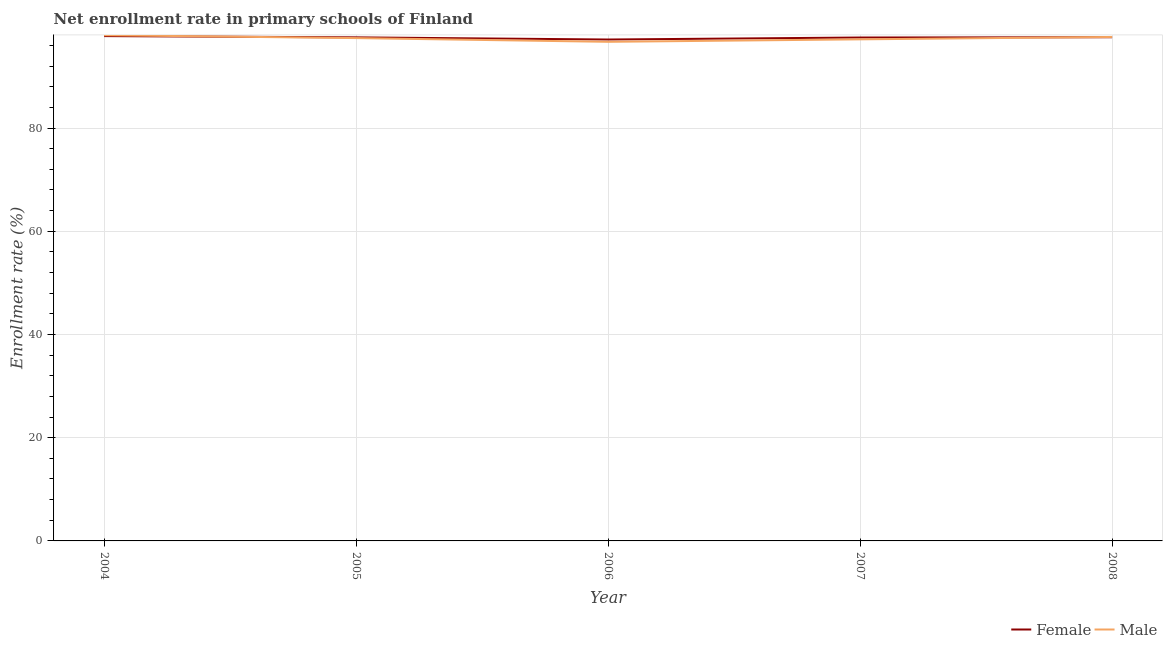Is the number of lines equal to the number of legend labels?
Make the answer very short. Yes. What is the enrollment rate of female students in 2007?
Your answer should be compact. 97.54. Across all years, what is the maximum enrollment rate of female students?
Provide a succinct answer. 97.82. Across all years, what is the minimum enrollment rate of male students?
Offer a terse response. 96.71. In which year was the enrollment rate of female students maximum?
Provide a short and direct response. 2004. What is the total enrollment rate of female students in the graph?
Provide a succinct answer. 487.68. What is the difference between the enrollment rate of male students in 2004 and that in 2005?
Offer a terse response. 0.56. What is the difference between the enrollment rate of male students in 2005 and the enrollment rate of female students in 2004?
Keep it short and to the point. -0.39. What is the average enrollment rate of female students per year?
Your answer should be very brief. 97.54. In the year 2008, what is the difference between the enrollment rate of male students and enrollment rate of female students?
Provide a short and direct response. 0.05. In how many years, is the enrollment rate of female students greater than 40 %?
Offer a very short reply. 5. What is the ratio of the enrollment rate of male students in 2006 to that in 2007?
Your answer should be compact. 1. Is the difference between the enrollment rate of female students in 2004 and 2005 greater than the difference between the enrollment rate of male students in 2004 and 2005?
Your answer should be very brief. No. What is the difference between the highest and the second highest enrollment rate of female students?
Your answer should be compact. 0.22. What is the difference between the highest and the lowest enrollment rate of female students?
Make the answer very short. 0.66. Does the enrollment rate of female students monotonically increase over the years?
Keep it short and to the point. No. Is the enrollment rate of male students strictly greater than the enrollment rate of female students over the years?
Offer a very short reply. No. Is the enrollment rate of male students strictly less than the enrollment rate of female students over the years?
Ensure brevity in your answer.  No. How many years are there in the graph?
Offer a terse response. 5. What is the difference between two consecutive major ticks on the Y-axis?
Offer a terse response. 20. Does the graph contain grids?
Ensure brevity in your answer.  Yes. What is the title of the graph?
Offer a terse response. Net enrollment rate in primary schools of Finland. What is the label or title of the X-axis?
Offer a very short reply. Year. What is the label or title of the Y-axis?
Make the answer very short. Enrollment rate (%). What is the Enrollment rate (%) of Female in 2004?
Keep it short and to the point. 97.82. What is the Enrollment rate (%) of Male in 2004?
Your answer should be compact. 97.99. What is the Enrollment rate (%) of Female in 2005?
Offer a very short reply. 97.57. What is the Enrollment rate (%) in Male in 2005?
Offer a terse response. 97.43. What is the Enrollment rate (%) of Female in 2006?
Provide a short and direct response. 97.15. What is the Enrollment rate (%) in Male in 2006?
Keep it short and to the point. 96.71. What is the Enrollment rate (%) of Female in 2007?
Provide a succinct answer. 97.54. What is the Enrollment rate (%) in Male in 2007?
Offer a terse response. 97.19. What is the Enrollment rate (%) of Female in 2008?
Provide a succinct answer. 97.6. What is the Enrollment rate (%) in Male in 2008?
Provide a short and direct response. 97.65. Across all years, what is the maximum Enrollment rate (%) of Female?
Ensure brevity in your answer.  97.82. Across all years, what is the maximum Enrollment rate (%) of Male?
Provide a succinct answer. 97.99. Across all years, what is the minimum Enrollment rate (%) in Female?
Offer a terse response. 97.15. Across all years, what is the minimum Enrollment rate (%) in Male?
Make the answer very short. 96.71. What is the total Enrollment rate (%) in Female in the graph?
Your answer should be very brief. 487.68. What is the total Enrollment rate (%) of Male in the graph?
Provide a short and direct response. 486.96. What is the difference between the Enrollment rate (%) of Female in 2004 and that in 2005?
Provide a succinct answer. 0.24. What is the difference between the Enrollment rate (%) in Male in 2004 and that in 2005?
Your answer should be very brief. 0.56. What is the difference between the Enrollment rate (%) in Female in 2004 and that in 2006?
Your answer should be very brief. 0.66. What is the difference between the Enrollment rate (%) in Male in 2004 and that in 2006?
Keep it short and to the point. 1.28. What is the difference between the Enrollment rate (%) in Female in 2004 and that in 2007?
Your response must be concise. 0.27. What is the difference between the Enrollment rate (%) in Male in 2004 and that in 2007?
Ensure brevity in your answer.  0.8. What is the difference between the Enrollment rate (%) in Female in 2004 and that in 2008?
Offer a terse response. 0.22. What is the difference between the Enrollment rate (%) in Male in 2004 and that in 2008?
Offer a terse response. 0.34. What is the difference between the Enrollment rate (%) in Female in 2005 and that in 2006?
Offer a very short reply. 0.42. What is the difference between the Enrollment rate (%) of Male in 2005 and that in 2006?
Keep it short and to the point. 0.72. What is the difference between the Enrollment rate (%) of Female in 2005 and that in 2007?
Provide a short and direct response. 0.03. What is the difference between the Enrollment rate (%) of Male in 2005 and that in 2007?
Offer a very short reply. 0.24. What is the difference between the Enrollment rate (%) in Female in 2005 and that in 2008?
Offer a very short reply. -0.03. What is the difference between the Enrollment rate (%) of Male in 2005 and that in 2008?
Give a very brief answer. -0.22. What is the difference between the Enrollment rate (%) of Female in 2006 and that in 2007?
Your response must be concise. -0.39. What is the difference between the Enrollment rate (%) of Male in 2006 and that in 2007?
Offer a terse response. -0.48. What is the difference between the Enrollment rate (%) in Female in 2006 and that in 2008?
Offer a terse response. -0.44. What is the difference between the Enrollment rate (%) in Male in 2006 and that in 2008?
Make the answer very short. -0.94. What is the difference between the Enrollment rate (%) of Female in 2007 and that in 2008?
Your answer should be very brief. -0.05. What is the difference between the Enrollment rate (%) in Male in 2007 and that in 2008?
Provide a succinct answer. -0.47. What is the difference between the Enrollment rate (%) of Female in 2004 and the Enrollment rate (%) of Male in 2005?
Offer a terse response. 0.39. What is the difference between the Enrollment rate (%) in Female in 2004 and the Enrollment rate (%) in Male in 2006?
Your answer should be compact. 1.11. What is the difference between the Enrollment rate (%) of Female in 2004 and the Enrollment rate (%) of Male in 2007?
Give a very brief answer. 0.63. What is the difference between the Enrollment rate (%) of Female in 2004 and the Enrollment rate (%) of Male in 2008?
Give a very brief answer. 0.17. What is the difference between the Enrollment rate (%) in Female in 2005 and the Enrollment rate (%) in Male in 2006?
Your answer should be compact. 0.86. What is the difference between the Enrollment rate (%) of Female in 2005 and the Enrollment rate (%) of Male in 2007?
Offer a terse response. 0.39. What is the difference between the Enrollment rate (%) in Female in 2005 and the Enrollment rate (%) in Male in 2008?
Offer a very short reply. -0.08. What is the difference between the Enrollment rate (%) in Female in 2006 and the Enrollment rate (%) in Male in 2007?
Your answer should be compact. -0.03. What is the difference between the Enrollment rate (%) in Female in 2006 and the Enrollment rate (%) in Male in 2008?
Your answer should be very brief. -0.5. What is the difference between the Enrollment rate (%) of Female in 2007 and the Enrollment rate (%) of Male in 2008?
Offer a terse response. -0.11. What is the average Enrollment rate (%) of Female per year?
Provide a short and direct response. 97.54. What is the average Enrollment rate (%) in Male per year?
Offer a terse response. 97.39. In the year 2004, what is the difference between the Enrollment rate (%) in Female and Enrollment rate (%) in Male?
Your answer should be very brief. -0.17. In the year 2005, what is the difference between the Enrollment rate (%) in Female and Enrollment rate (%) in Male?
Offer a very short reply. 0.14. In the year 2006, what is the difference between the Enrollment rate (%) of Female and Enrollment rate (%) of Male?
Provide a succinct answer. 0.44. In the year 2007, what is the difference between the Enrollment rate (%) in Female and Enrollment rate (%) in Male?
Provide a short and direct response. 0.36. In the year 2008, what is the difference between the Enrollment rate (%) in Female and Enrollment rate (%) in Male?
Your answer should be very brief. -0.05. What is the ratio of the Enrollment rate (%) in Female in 2004 to that in 2005?
Your answer should be very brief. 1. What is the ratio of the Enrollment rate (%) of Female in 2004 to that in 2006?
Your response must be concise. 1.01. What is the ratio of the Enrollment rate (%) in Male in 2004 to that in 2006?
Make the answer very short. 1.01. What is the ratio of the Enrollment rate (%) in Female in 2004 to that in 2007?
Make the answer very short. 1. What is the ratio of the Enrollment rate (%) in Male in 2004 to that in 2007?
Give a very brief answer. 1.01. What is the ratio of the Enrollment rate (%) of Male in 2005 to that in 2006?
Your answer should be very brief. 1.01. What is the ratio of the Enrollment rate (%) of Female in 2006 to that in 2007?
Your response must be concise. 1. What is the ratio of the Enrollment rate (%) in Male in 2006 to that in 2007?
Your response must be concise. 1. What is the ratio of the Enrollment rate (%) in Female in 2006 to that in 2008?
Your answer should be compact. 1. What is the ratio of the Enrollment rate (%) in Male in 2006 to that in 2008?
Ensure brevity in your answer.  0.99. What is the ratio of the Enrollment rate (%) of Male in 2007 to that in 2008?
Provide a succinct answer. 1. What is the difference between the highest and the second highest Enrollment rate (%) of Female?
Provide a short and direct response. 0.22. What is the difference between the highest and the second highest Enrollment rate (%) in Male?
Your response must be concise. 0.34. What is the difference between the highest and the lowest Enrollment rate (%) in Female?
Make the answer very short. 0.66. What is the difference between the highest and the lowest Enrollment rate (%) in Male?
Offer a terse response. 1.28. 